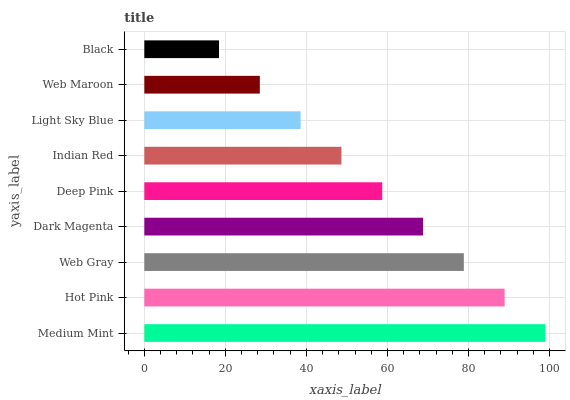Is Black the minimum?
Answer yes or no. Yes. Is Medium Mint the maximum?
Answer yes or no. Yes. Is Hot Pink the minimum?
Answer yes or no. No. Is Hot Pink the maximum?
Answer yes or no. No. Is Medium Mint greater than Hot Pink?
Answer yes or no. Yes. Is Hot Pink less than Medium Mint?
Answer yes or no. Yes. Is Hot Pink greater than Medium Mint?
Answer yes or no. No. Is Medium Mint less than Hot Pink?
Answer yes or no. No. Is Deep Pink the high median?
Answer yes or no. Yes. Is Deep Pink the low median?
Answer yes or no. Yes. Is Medium Mint the high median?
Answer yes or no. No. Is Web Gray the low median?
Answer yes or no. No. 